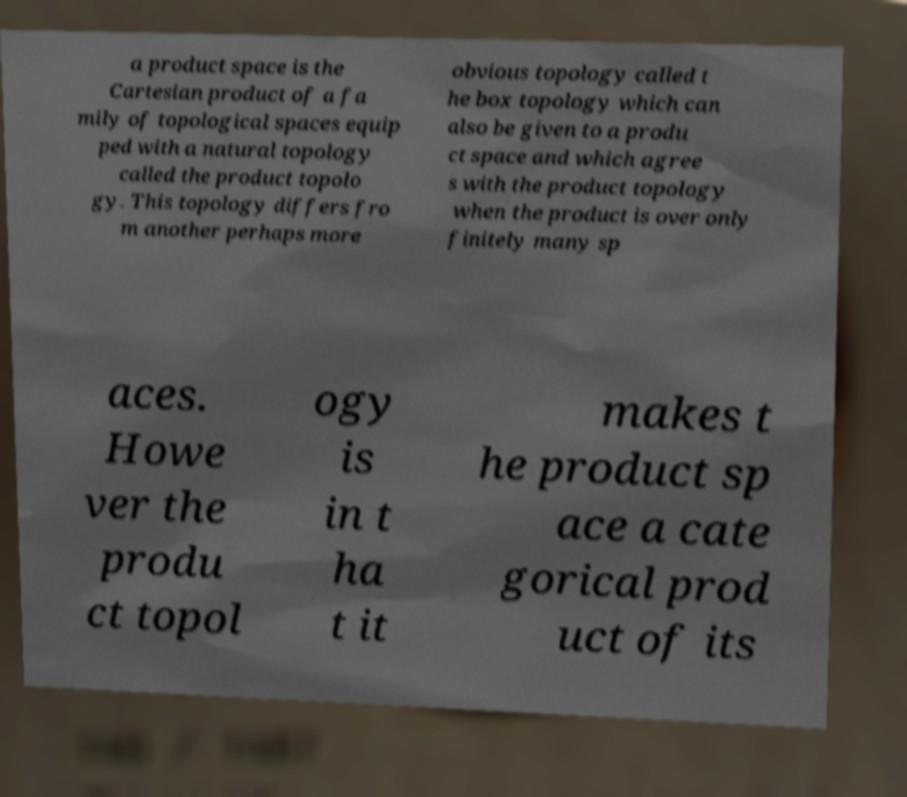Could you assist in decoding the text presented in this image and type it out clearly? a product space is the Cartesian product of a fa mily of topological spaces equip ped with a natural topology called the product topolo gy. This topology differs fro m another perhaps more obvious topology called t he box topology which can also be given to a produ ct space and which agree s with the product topology when the product is over only finitely many sp aces. Howe ver the produ ct topol ogy is in t ha t it makes t he product sp ace a cate gorical prod uct of its 